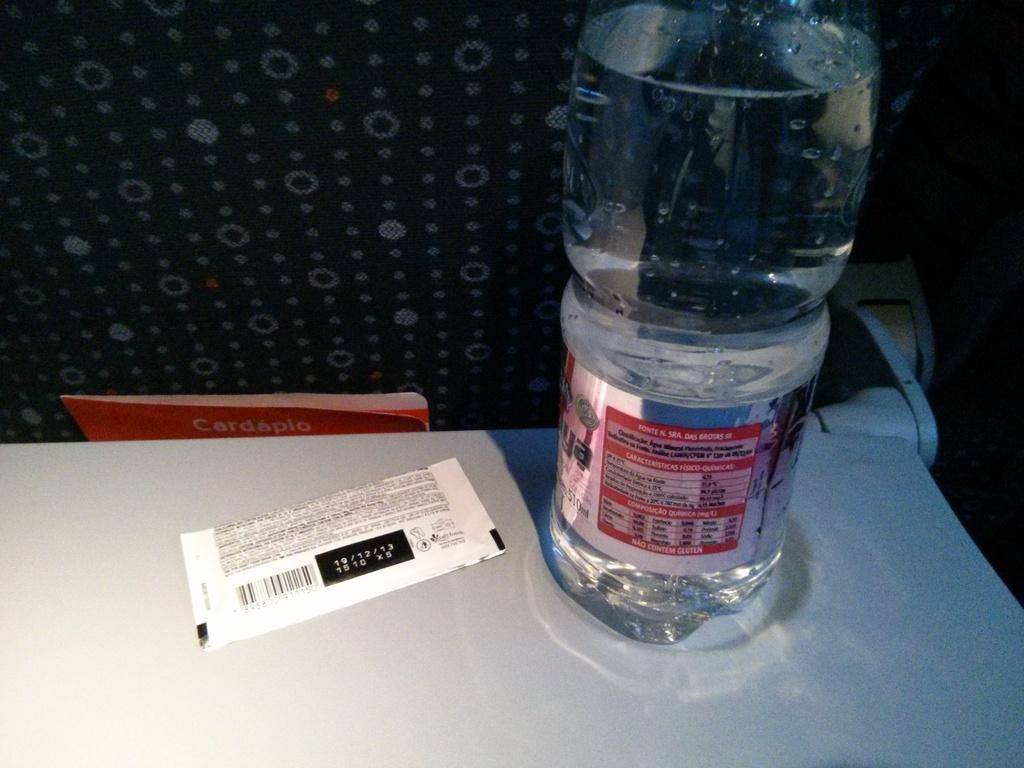<image>
Render a clear and concise summary of the photo. The date shown on the ticket on the table is 19/12/13. 